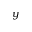Convert formula to latex. <formula><loc_0><loc_0><loc_500><loc_500>y</formula> 